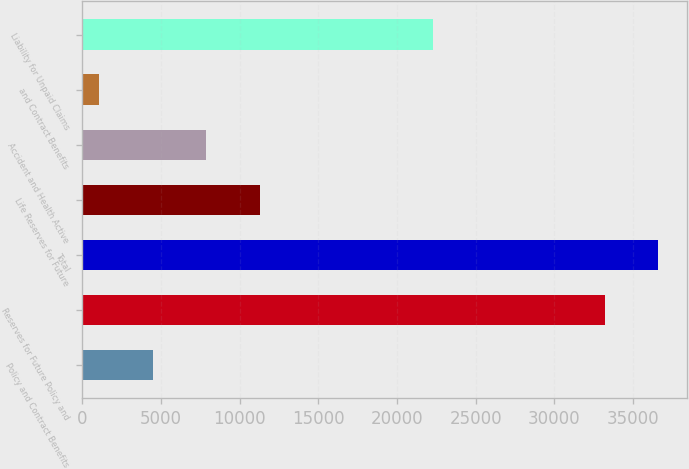Convert chart. <chart><loc_0><loc_0><loc_500><loc_500><bar_chart><fcel>Policy and Contract Benefits<fcel>Reserves for Future Policy and<fcel>Total<fcel>Life Reserves for Future<fcel>Accident and Health Active<fcel>and Contract Benefits<fcel>Liability for Unpaid Claims<nl><fcel>4489.17<fcel>33224.8<fcel>36622.3<fcel>11284.1<fcel>7886.64<fcel>1091.7<fcel>22285.1<nl></chart> 